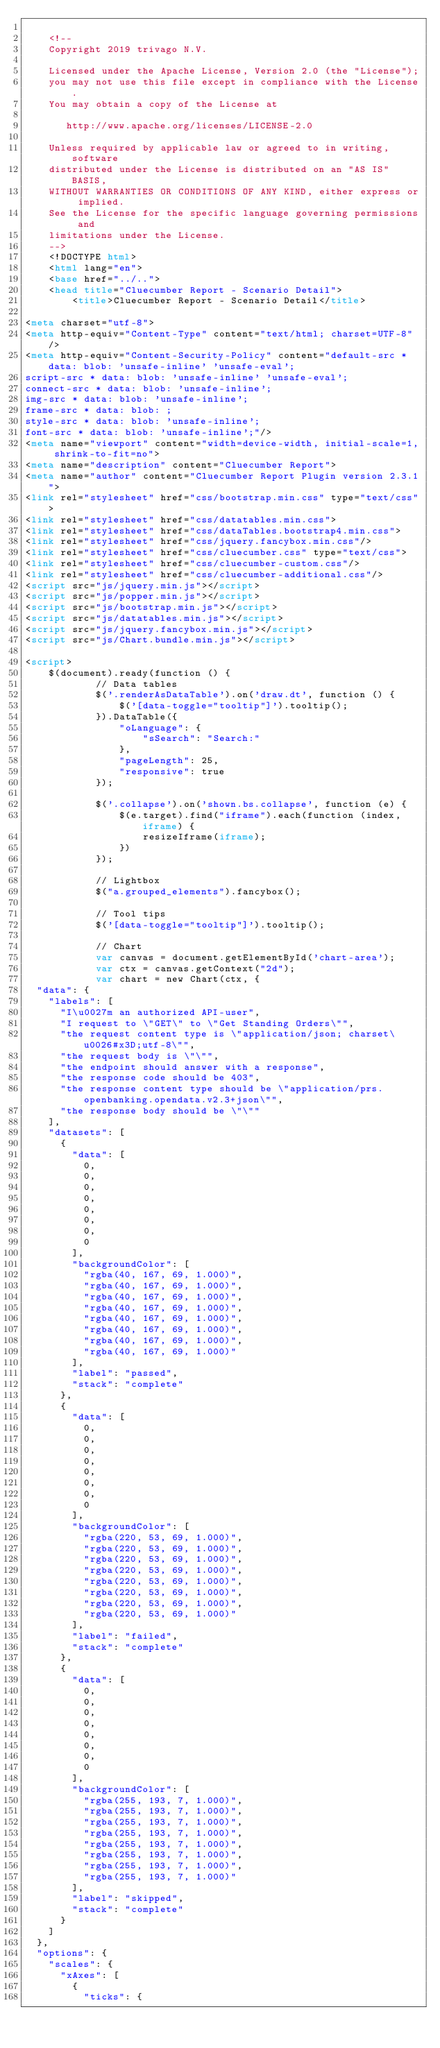Convert code to text. <code><loc_0><loc_0><loc_500><loc_500><_HTML_>
    <!--
    Copyright 2019 trivago N.V.

    Licensed under the Apache License, Version 2.0 (the "License");
    you may not use this file except in compliance with the License.
    You may obtain a copy of the License at

       http://www.apache.org/licenses/LICENSE-2.0

    Unless required by applicable law or agreed to in writing, software
    distributed under the License is distributed on an "AS IS" BASIS,
    WITHOUT WARRANTIES OR CONDITIONS OF ANY KIND, either express or implied.
    See the License for the specific language governing permissions and
    limitations under the License.
    -->
    <!DOCTYPE html>
    <html lang="en">
    <base href="../..">
    <head title="Cluecumber Report - Scenario Detail">
        <title>Cluecumber Report - Scenario Detail</title>

<meta charset="utf-8">
<meta http-equiv="Content-Type" content="text/html; charset=UTF-8"/>
<meta http-equiv="Content-Security-Policy" content="default-src *  data: blob: 'unsafe-inline' 'unsafe-eval';
script-src * data: blob: 'unsafe-inline' 'unsafe-eval';
connect-src * data: blob: 'unsafe-inline';
img-src * data: blob: 'unsafe-inline';
frame-src * data: blob: ;
style-src * data: blob: 'unsafe-inline';
font-src * data: blob: 'unsafe-inline';"/>
<meta name="viewport" content="width=device-width, initial-scale=1, shrink-to-fit=no">
<meta name="description" content="Cluecumber Report">
<meta name="author" content="Cluecumber Report Plugin version 2.3.1">
<link rel="stylesheet" href="css/bootstrap.min.css" type="text/css">
<link rel="stylesheet" href="css/datatables.min.css">
<link rel="stylesheet" href="css/dataTables.bootstrap4.min.css">
<link rel="stylesheet" href="css/jquery.fancybox.min.css"/>
<link rel="stylesheet" href="css/cluecumber.css" type="text/css">
<link rel="stylesheet" href="css/cluecumber-custom.css"/>
<link rel="stylesheet" href="css/cluecumber-additional.css"/>
<script src="js/jquery.min.js"></script>
<script src="js/popper.min.js"></script>
<script src="js/bootstrap.min.js"></script>
<script src="js/datatables.min.js"></script>
<script src="js/jquery.fancybox.min.js"></script>
<script src="js/Chart.bundle.min.js"></script>

<script>
    $(document).ready(function () {
            // Data tables
            $('.renderAsDataTable').on('draw.dt', function () {
                $('[data-toggle="tooltip"]').tooltip();
            }).DataTable({
                "oLanguage": {
                    "sSearch": "Search:"
                },
                "pageLength": 25,
                "responsive": true
            });

            $('.collapse').on('shown.bs.collapse', function (e) {
                $(e.target).find("iframe").each(function (index, iframe) {
                    resizeIframe(iframe);
                })
            });

            // Lightbox
            $("a.grouped_elements").fancybox();

            // Tool tips
            $('[data-toggle="tooltip"]').tooltip();

            // Chart
            var canvas = document.getElementById('chart-area');
            var ctx = canvas.getContext("2d");
            var chart = new Chart(ctx, {
  "data": {
    "labels": [
      "I\u0027m an authorized API-user",
      "I request to \"GET\" to \"Get Standing Orders\"",
      "the request content type is \"application/json; charset\u0026#x3D;utf-8\"",
      "the request body is \"\"",
      "the endpoint should answer with a response",
      "the response code should be 403",
      "the response content type should be \"application/prs.openbanking.opendata.v2.3+json\"",
      "the response body should be \"\""
    ],
    "datasets": [
      {
        "data": [
          0,
          0,
          0,
          0,
          0,
          0,
          0,
          0
        ],
        "backgroundColor": [
          "rgba(40, 167, 69, 1.000)",
          "rgba(40, 167, 69, 1.000)",
          "rgba(40, 167, 69, 1.000)",
          "rgba(40, 167, 69, 1.000)",
          "rgba(40, 167, 69, 1.000)",
          "rgba(40, 167, 69, 1.000)",
          "rgba(40, 167, 69, 1.000)",
          "rgba(40, 167, 69, 1.000)"
        ],
        "label": "passed",
        "stack": "complete"
      },
      {
        "data": [
          0,
          0,
          0,
          0,
          0,
          0,
          0,
          0
        ],
        "backgroundColor": [
          "rgba(220, 53, 69, 1.000)",
          "rgba(220, 53, 69, 1.000)",
          "rgba(220, 53, 69, 1.000)",
          "rgba(220, 53, 69, 1.000)",
          "rgba(220, 53, 69, 1.000)",
          "rgba(220, 53, 69, 1.000)",
          "rgba(220, 53, 69, 1.000)",
          "rgba(220, 53, 69, 1.000)"
        ],
        "label": "failed",
        "stack": "complete"
      },
      {
        "data": [
          0,
          0,
          0,
          0,
          0,
          0,
          0,
          0
        ],
        "backgroundColor": [
          "rgba(255, 193, 7, 1.000)",
          "rgba(255, 193, 7, 1.000)",
          "rgba(255, 193, 7, 1.000)",
          "rgba(255, 193, 7, 1.000)",
          "rgba(255, 193, 7, 1.000)",
          "rgba(255, 193, 7, 1.000)",
          "rgba(255, 193, 7, 1.000)",
          "rgba(255, 193, 7, 1.000)"
        ],
        "label": "skipped",
        "stack": "complete"
      }
    ]
  },
  "options": {
    "scales": {
      "xAxes": [
        {
          "ticks": {</code> 